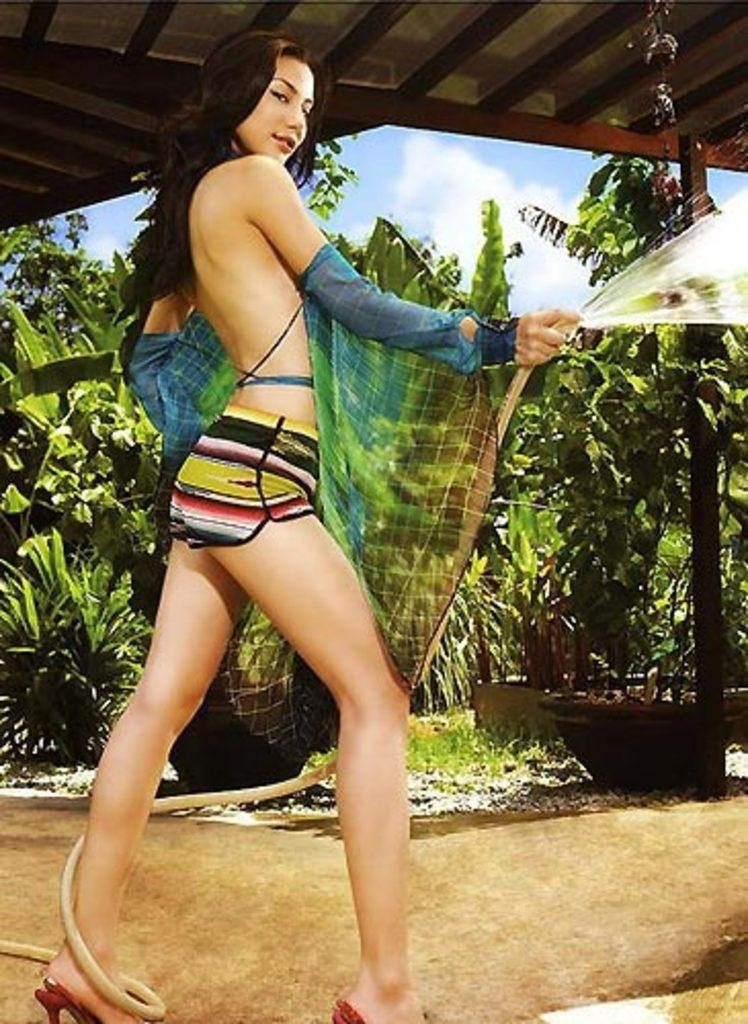What is the main subject of the image? There is a person standing in the image. What is the person holding in the image? The person is holding a pipe. What can be seen in the background of the image? There are trees and a shed visible in the background. How would you describe the sky in the image? The sky is blue and white in the image. What advice does the person in the image give to the achiever? There is no indication in the image that the person is giving advice to an achiever, as the image only shows a person holding a pipe and the background elements. 